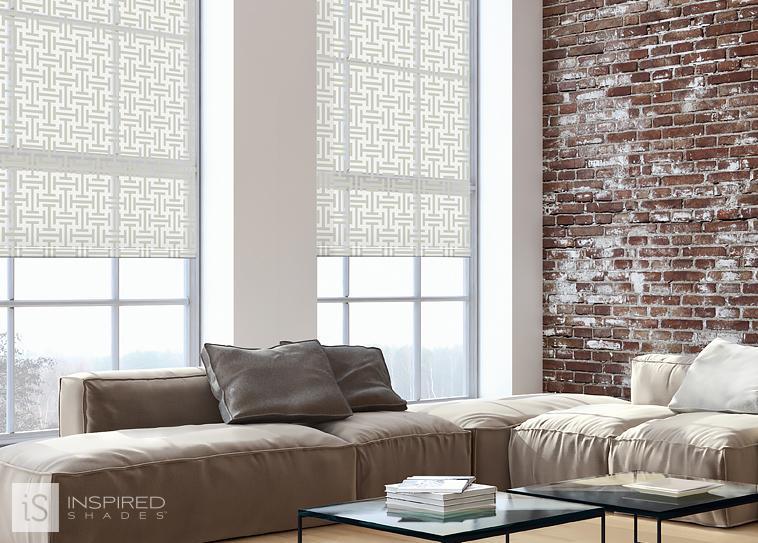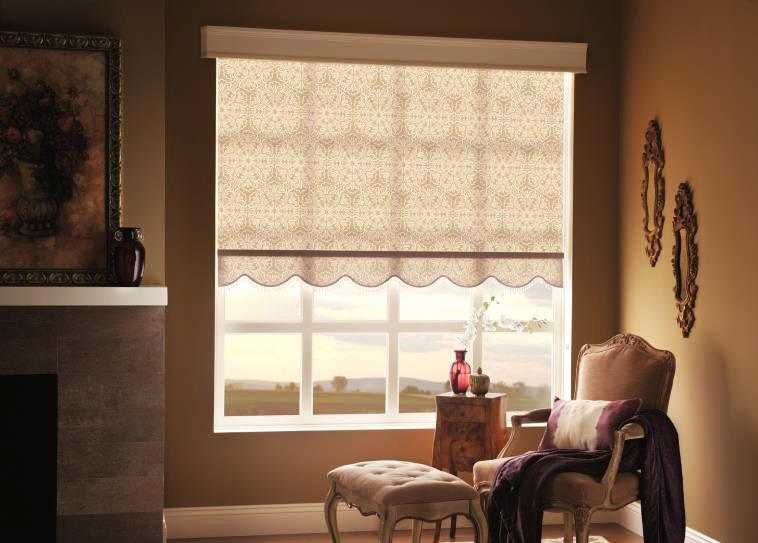The first image is the image on the left, the second image is the image on the right. For the images displayed, is the sentence "All the shades are partially open." factually correct? Answer yes or no. Yes. The first image is the image on the left, the second image is the image on the right. Assess this claim about the two images: "There are two windows in the left image.". Correct or not? Answer yes or no. Yes. 